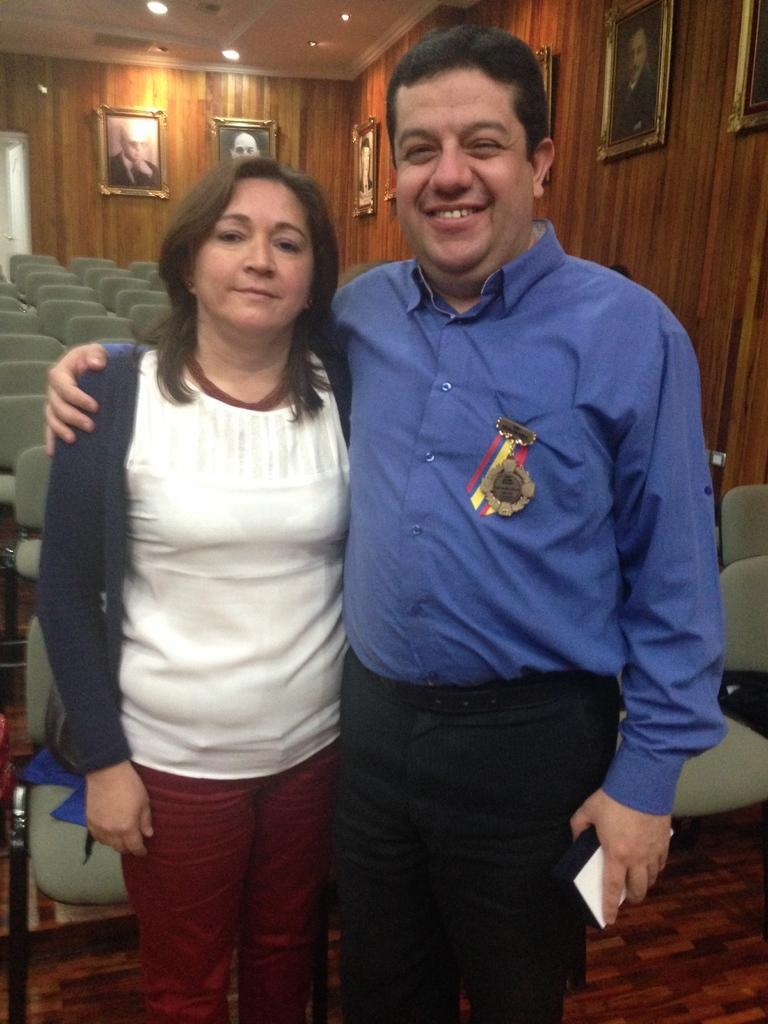In one or two sentences, can you explain what this image depicts? In the foreground of this image, there is a man and a man standing and the man is holding a mobile and the woman is carrying a bag. In the background, there are chairs, lights to the ceiling and frames on the wall. 